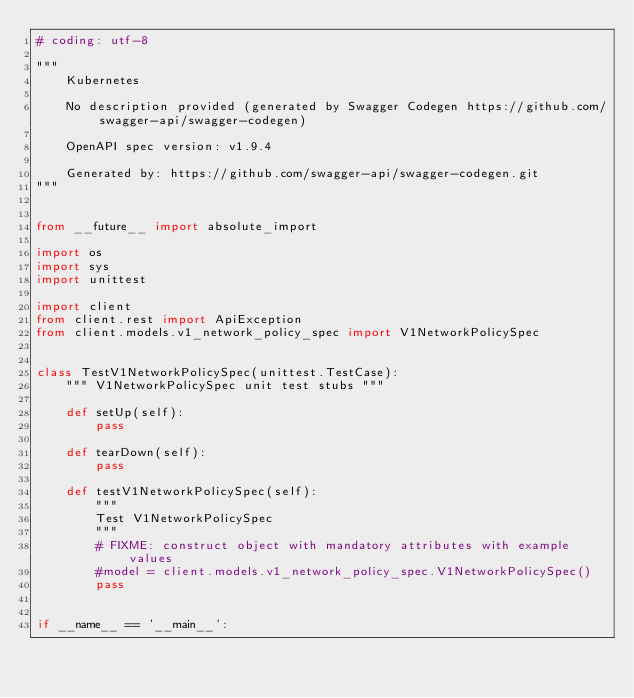<code> <loc_0><loc_0><loc_500><loc_500><_Python_># coding: utf-8

"""
    Kubernetes

    No description provided (generated by Swagger Codegen https://github.com/swagger-api/swagger-codegen)

    OpenAPI spec version: v1.9.4
    
    Generated by: https://github.com/swagger-api/swagger-codegen.git
"""


from __future__ import absolute_import

import os
import sys
import unittest

import client
from client.rest import ApiException
from client.models.v1_network_policy_spec import V1NetworkPolicySpec


class TestV1NetworkPolicySpec(unittest.TestCase):
    """ V1NetworkPolicySpec unit test stubs """

    def setUp(self):
        pass

    def tearDown(self):
        pass

    def testV1NetworkPolicySpec(self):
        """
        Test V1NetworkPolicySpec
        """
        # FIXME: construct object with mandatory attributes with example values
        #model = client.models.v1_network_policy_spec.V1NetworkPolicySpec()
        pass


if __name__ == '__main__':</code> 